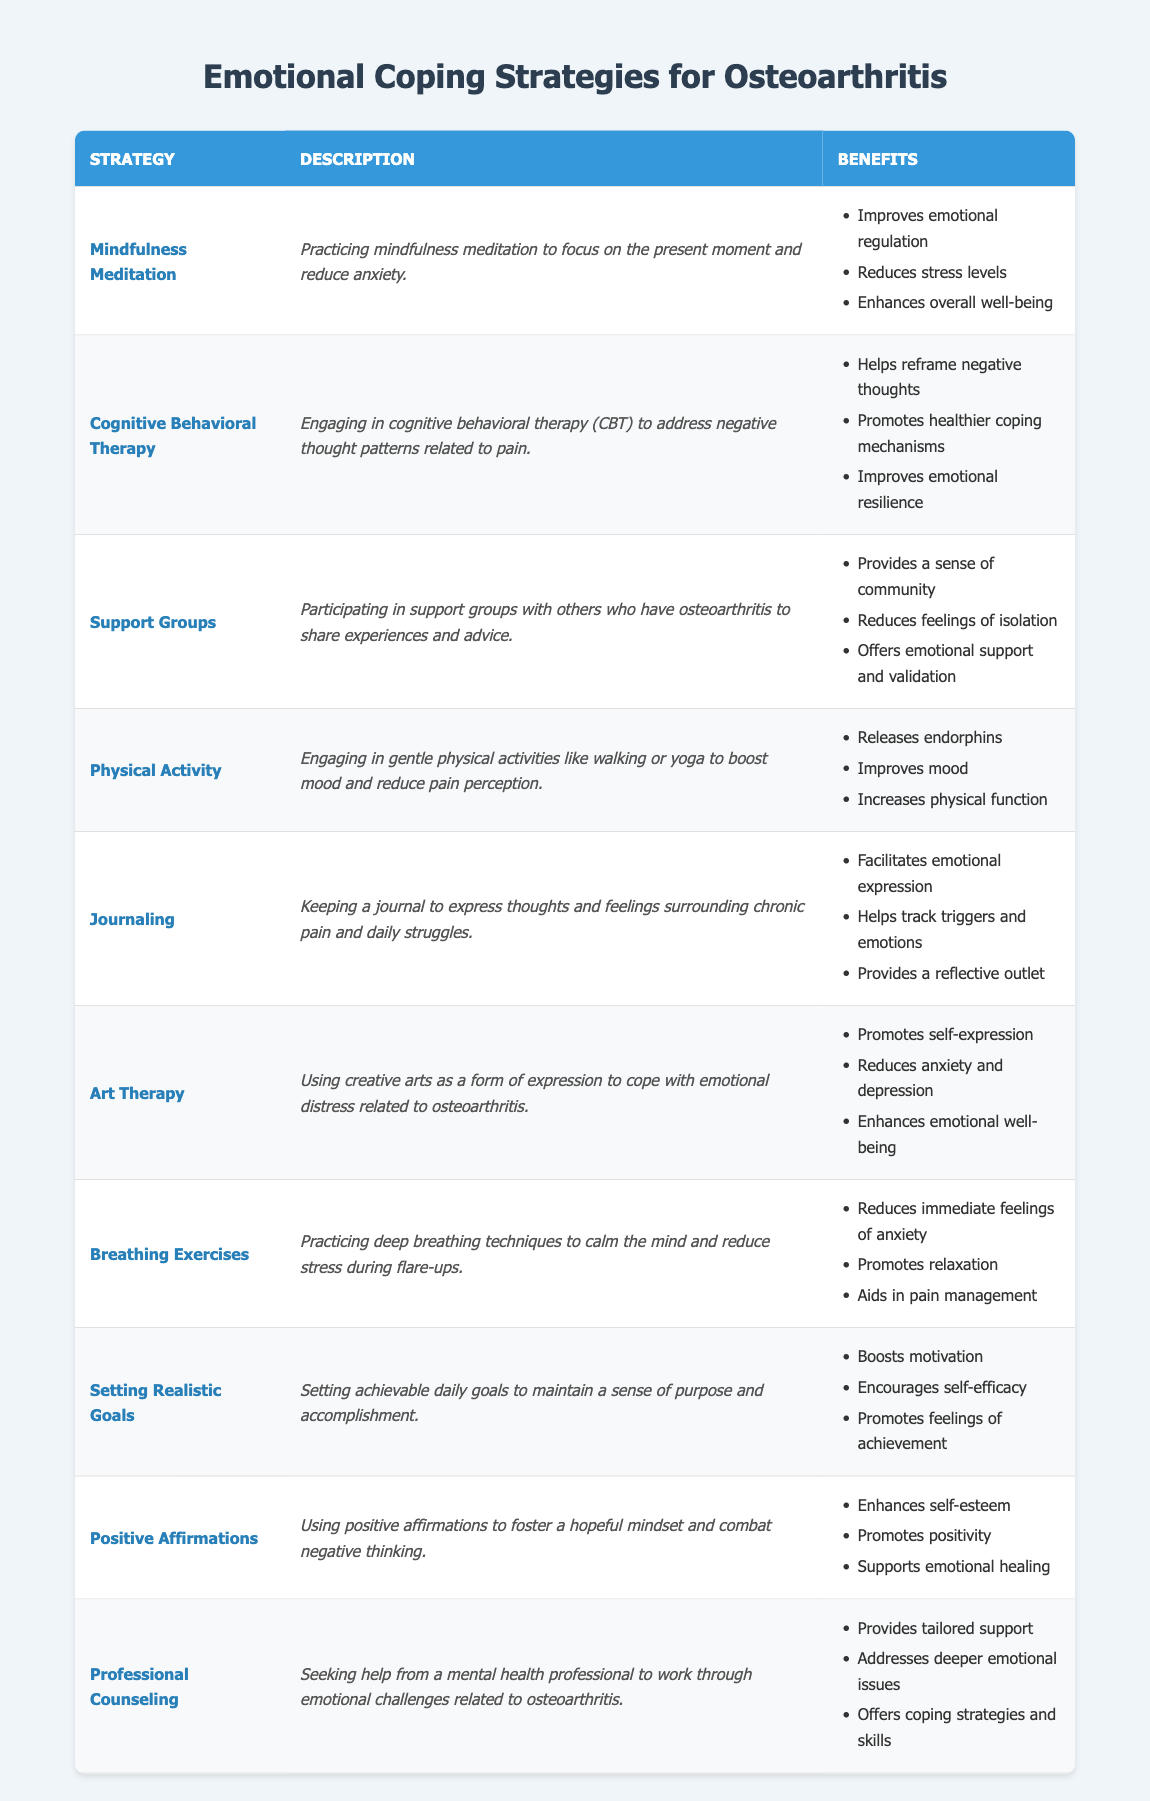What is the strategy that involves expressing oneself through creative arts? According to the table, the strategy that uses creative arts for emotional expression is "Art Therapy." This is directly mentioned in the "Strategy" column.
Answer: Art Therapy Which strategy focuses on reducing anxiety during flare-ups? The strategy that emphasizes calming the mind and reducing stress during flare-ups is "Breathing Exercises." This can be found in the "Description" column of the table.
Answer: Breathing Exercises Do all strategies in the table promote emotional well-being? Not all strategies explicitly mention promoting emotional well-being, but many do. For instance, "Art Therapy" and "Mindfulness Meditation" list enhancing emotional well-being as a benefit, indicating that they address this aspect.
Answer: No How many benefits does "Cognitive Behavioral Therapy" provide? The "Cognitive Behavioral Therapy" strategy is listed with three benefits in the table. Specifically, they are "Helps reframe negative thoughts," "Promotes healthier coping mechanisms," and "Improves emotional resilience."
Answer: 3 Identify the strategy that aids both in emotional support and reduces isolation. The strategy that offers emotional support and reduces feelings of isolation is "Support Groups." This is explicitly detailed in both the "Description" and "Benefits" sections of the table.
Answer: Support Groups Is there a strategy that includes physical activity to enhance mood? Yes, "Physical Activity" is specifically mentioned as a strategy that involves engaging in gentle activities like walking or yoga to boost mood and help alleviate pain perception.
Answer: Yes Which two strategies are designed to promote self-expression? The two strategies meant to encourage self-expression are "Journaling" and "Art Therapy." Both strategies focus on different forms of expressing thoughts and emotions.
Answer: Journaling, Art Therapy What benefits do "Positive Affirmations" aim to enhance? The benefits of "Positive Affirmations" are listed as enhancing self-esteem, promoting positivity, and supporting emotional healing. These are specifically mentioned in the "Benefits" column for this strategy.
Answer: Enhances self-esteem, promotes positivity, supports emotional healing Which strategy addresses deeper emotional issues through professional help? The "Professional Counseling" strategy provides tailored support and focuses on addressing deeper emotional issues related to osteoarthritis, as stated in the "Description" column.
Answer: Professional Counseling 